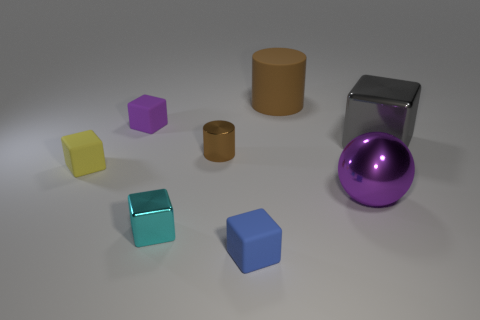Subtract all cyan metallic cubes. How many cubes are left? 4 Subtract all gray cubes. How many cubes are left? 4 Subtract all brown blocks. Subtract all cyan cylinders. How many blocks are left? 5 Add 2 tiny gray shiny blocks. How many objects exist? 10 Subtract all balls. How many objects are left? 7 Add 1 large purple metallic things. How many large purple metallic things are left? 2 Add 8 blue metal blocks. How many blue metal blocks exist? 8 Subtract 0 cyan cylinders. How many objects are left? 8 Subtract all tiny green matte cubes. Subtract all gray things. How many objects are left? 7 